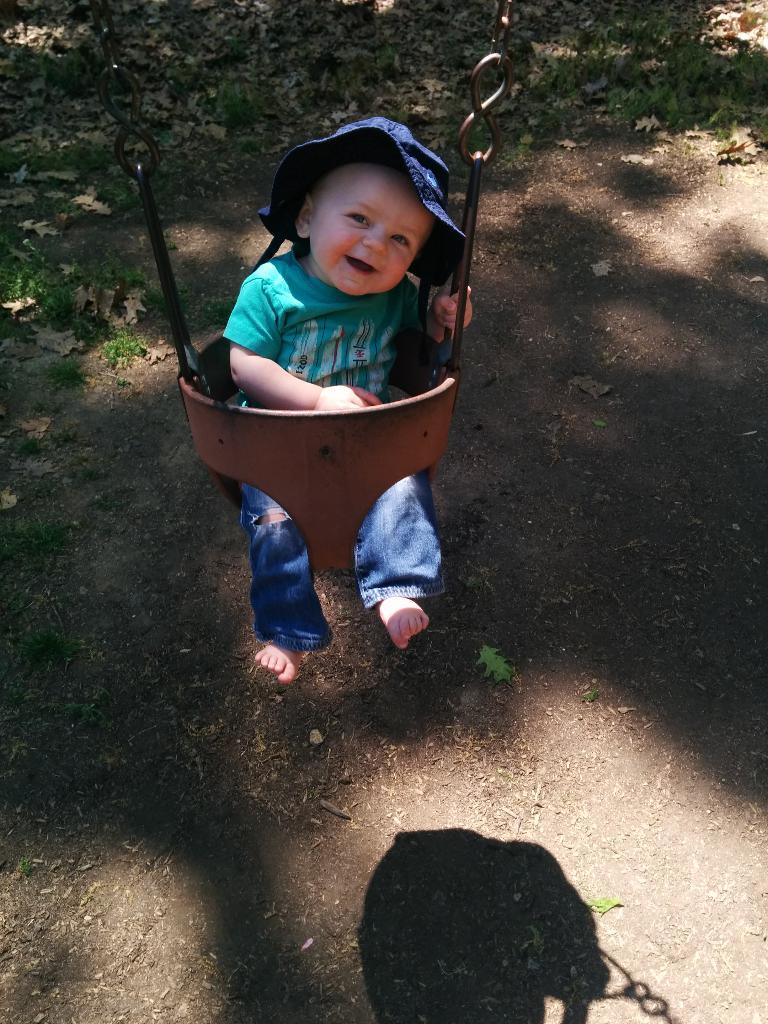What is the main subject of the image? There is a baby in the image. What is the baby sitting on? The baby is sitting on an object. What color is the baby's shirt? The baby is wearing a green shirt. What color are the baby's pants? The baby is wearing blue pants. What type of headwear is the baby wearing? The baby is wearing a blue cap. What can be seen in the background of the image? There are dried leaves in the background of the image. What type of doll is sitting next to the baby in the image? There is no doll present in the image; it only features a baby sitting on an object. What sound does the alarm make in the image? There is no alarm present in the image. 